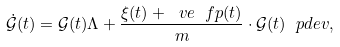Convert formula to latex. <formula><loc_0><loc_0><loc_500><loc_500>\dot { \mathcal { G } } ( t ) = \mathcal { G } ( t ) \Lambda + \frac { \xi ( t ) + \ v e \ f p ( t ) } { m } \cdot \mathcal { G } ( t ) \ p d e { v } ,</formula> 